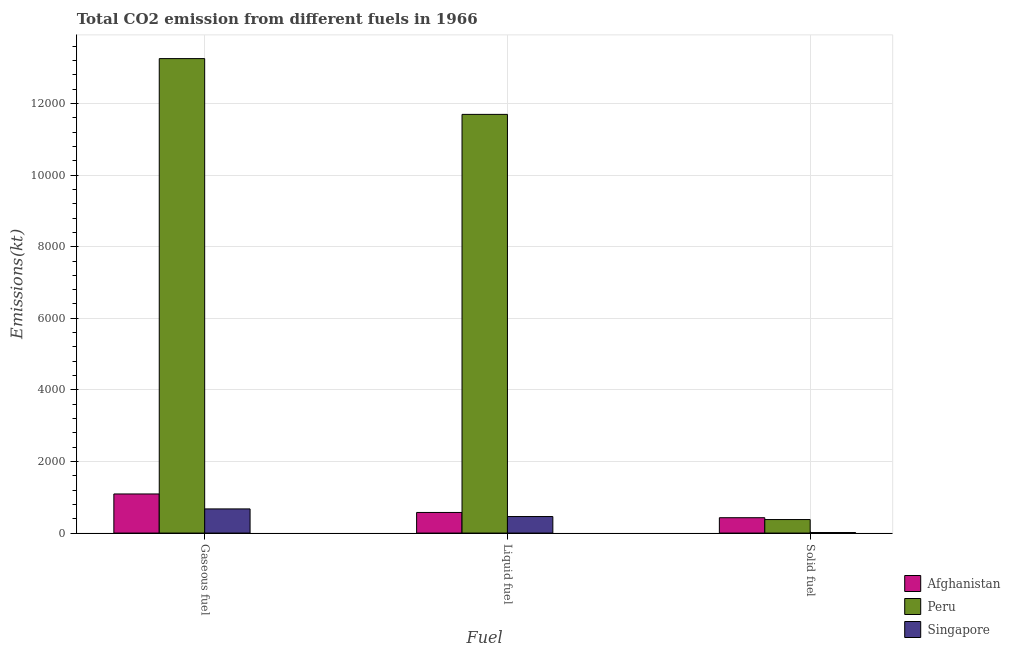How many groups of bars are there?
Keep it short and to the point. 3. How many bars are there on the 1st tick from the left?
Make the answer very short. 3. How many bars are there on the 3rd tick from the right?
Offer a very short reply. 3. What is the label of the 3rd group of bars from the left?
Your response must be concise. Solid fuel. What is the amount of co2 emissions from gaseous fuel in Singapore?
Ensure brevity in your answer.  674.73. Across all countries, what is the maximum amount of co2 emissions from gaseous fuel?
Offer a very short reply. 1.33e+04. Across all countries, what is the minimum amount of co2 emissions from liquid fuel?
Your answer should be very brief. 462.04. In which country was the amount of co2 emissions from gaseous fuel maximum?
Keep it short and to the point. Peru. In which country was the amount of co2 emissions from solid fuel minimum?
Offer a terse response. Singapore. What is the total amount of co2 emissions from gaseous fuel in the graph?
Keep it short and to the point. 1.50e+04. What is the difference between the amount of co2 emissions from gaseous fuel in Afghanistan and that in Peru?
Offer a very short reply. -1.22e+04. What is the difference between the amount of co2 emissions from gaseous fuel in Peru and the amount of co2 emissions from liquid fuel in Afghanistan?
Give a very brief answer. 1.27e+04. What is the average amount of co2 emissions from gaseous fuel per country?
Give a very brief answer. 5007.9. What is the difference between the amount of co2 emissions from solid fuel and amount of co2 emissions from gaseous fuel in Afghanistan?
Offer a very short reply. -663.73. What is the ratio of the amount of co2 emissions from solid fuel in Afghanistan to that in Peru?
Keep it short and to the point. 1.14. Is the amount of co2 emissions from gaseous fuel in Peru less than that in Singapore?
Give a very brief answer. No. What is the difference between the highest and the second highest amount of co2 emissions from liquid fuel?
Offer a very short reply. 1.11e+04. What is the difference between the highest and the lowest amount of co2 emissions from solid fuel?
Keep it short and to the point. 414.37. Is the sum of the amount of co2 emissions from gaseous fuel in Singapore and Peru greater than the maximum amount of co2 emissions from solid fuel across all countries?
Give a very brief answer. Yes. What does the 1st bar from the right in Solid fuel represents?
Offer a very short reply. Singapore. Is it the case that in every country, the sum of the amount of co2 emissions from gaseous fuel and amount of co2 emissions from liquid fuel is greater than the amount of co2 emissions from solid fuel?
Your response must be concise. Yes. How many countries are there in the graph?
Provide a succinct answer. 3. Where does the legend appear in the graph?
Your answer should be very brief. Bottom right. What is the title of the graph?
Provide a short and direct response. Total CO2 emission from different fuels in 1966. Does "Bhutan" appear as one of the legend labels in the graph?
Provide a succinct answer. No. What is the label or title of the X-axis?
Offer a very short reply. Fuel. What is the label or title of the Y-axis?
Make the answer very short. Emissions(kt). What is the Emissions(kt) in Afghanistan in Gaseous fuel?
Make the answer very short. 1092.77. What is the Emissions(kt) in Peru in Gaseous fuel?
Your answer should be compact. 1.33e+04. What is the Emissions(kt) of Singapore in Gaseous fuel?
Ensure brevity in your answer.  674.73. What is the Emissions(kt) of Afghanistan in Liquid fuel?
Give a very brief answer. 575.72. What is the Emissions(kt) in Peru in Liquid fuel?
Offer a terse response. 1.17e+04. What is the Emissions(kt) of Singapore in Liquid fuel?
Your answer should be compact. 462.04. What is the Emissions(kt) of Afghanistan in Solid fuel?
Make the answer very short. 429.04. What is the Emissions(kt) of Peru in Solid fuel?
Ensure brevity in your answer.  377.7. What is the Emissions(kt) of Singapore in Solid fuel?
Give a very brief answer. 14.67. Across all Fuel, what is the maximum Emissions(kt) in Afghanistan?
Offer a terse response. 1092.77. Across all Fuel, what is the maximum Emissions(kt) of Peru?
Give a very brief answer. 1.33e+04. Across all Fuel, what is the maximum Emissions(kt) in Singapore?
Your response must be concise. 674.73. Across all Fuel, what is the minimum Emissions(kt) of Afghanistan?
Offer a terse response. 429.04. Across all Fuel, what is the minimum Emissions(kt) in Peru?
Offer a terse response. 377.7. Across all Fuel, what is the minimum Emissions(kt) in Singapore?
Provide a succinct answer. 14.67. What is the total Emissions(kt) in Afghanistan in the graph?
Your answer should be compact. 2097.52. What is the total Emissions(kt) in Peru in the graph?
Offer a terse response. 2.53e+04. What is the total Emissions(kt) of Singapore in the graph?
Keep it short and to the point. 1151.44. What is the difference between the Emissions(kt) in Afghanistan in Gaseous fuel and that in Liquid fuel?
Give a very brief answer. 517.05. What is the difference between the Emissions(kt) of Peru in Gaseous fuel and that in Liquid fuel?
Your response must be concise. 1558.47. What is the difference between the Emissions(kt) of Singapore in Gaseous fuel and that in Liquid fuel?
Make the answer very short. 212.69. What is the difference between the Emissions(kt) of Afghanistan in Gaseous fuel and that in Solid fuel?
Provide a succinct answer. 663.73. What is the difference between the Emissions(kt) in Peru in Gaseous fuel and that in Solid fuel?
Ensure brevity in your answer.  1.29e+04. What is the difference between the Emissions(kt) in Singapore in Gaseous fuel and that in Solid fuel?
Provide a succinct answer. 660.06. What is the difference between the Emissions(kt) of Afghanistan in Liquid fuel and that in Solid fuel?
Keep it short and to the point. 146.68. What is the difference between the Emissions(kt) in Peru in Liquid fuel and that in Solid fuel?
Give a very brief answer. 1.13e+04. What is the difference between the Emissions(kt) in Singapore in Liquid fuel and that in Solid fuel?
Your answer should be very brief. 447.37. What is the difference between the Emissions(kt) of Afghanistan in Gaseous fuel and the Emissions(kt) of Peru in Liquid fuel?
Make the answer very short. -1.06e+04. What is the difference between the Emissions(kt) in Afghanistan in Gaseous fuel and the Emissions(kt) in Singapore in Liquid fuel?
Provide a succinct answer. 630.72. What is the difference between the Emissions(kt) in Peru in Gaseous fuel and the Emissions(kt) in Singapore in Liquid fuel?
Make the answer very short. 1.28e+04. What is the difference between the Emissions(kt) of Afghanistan in Gaseous fuel and the Emissions(kt) of Peru in Solid fuel?
Make the answer very short. 715.07. What is the difference between the Emissions(kt) in Afghanistan in Gaseous fuel and the Emissions(kt) in Singapore in Solid fuel?
Offer a terse response. 1078.1. What is the difference between the Emissions(kt) of Peru in Gaseous fuel and the Emissions(kt) of Singapore in Solid fuel?
Offer a terse response. 1.32e+04. What is the difference between the Emissions(kt) of Afghanistan in Liquid fuel and the Emissions(kt) of Peru in Solid fuel?
Provide a succinct answer. 198.02. What is the difference between the Emissions(kt) of Afghanistan in Liquid fuel and the Emissions(kt) of Singapore in Solid fuel?
Your response must be concise. 561.05. What is the difference between the Emissions(kt) of Peru in Liquid fuel and the Emissions(kt) of Singapore in Solid fuel?
Your answer should be very brief. 1.17e+04. What is the average Emissions(kt) of Afghanistan per Fuel?
Provide a succinct answer. 699.17. What is the average Emissions(kt) of Peru per Fuel?
Offer a very short reply. 8443.88. What is the average Emissions(kt) in Singapore per Fuel?
Provide a short and direct response. 383.81. What is the difference between the Emissions(kt) of Afghanistan and Emissions(kt) of Peru in Gaseous fuel?
Keep it short and to the point. -1.22e+04. What is the difference between the Emissions(kt) in Afghanistan and Emissions(kt) in Singapore in Gaseous fuel?
Ensure brevity in your answer.  418.04. What is the difference between the Emissions(kt) in Peru and Emissions(kt) in Singapore in Gaseous fuel?
Offer a very short reply. 1.26e+04. What is the difference between the Emissions(kt) of Afghanistan and Emissions(kt) of Peru in Liquid fuel?
Offer a terse response. -1.11e+04. What is the difference between the Emissions(kt) in Afghanistan and Emissions(kt) in Singapore in Liquid fuel?
Keep it short and to the point. 113.68. What is the difference between the Emissions(kt) in Peru and Emissions(kt) in Singapore in Liquid fuel?
Give a very brief answer. 1.12e+04. What is the difference between the Emissions(kt) of Afghanistan and Emissions(kt) of Peru in Solid fuel?
Your response must be concise. 51.34. What is the difference between the Emissions(kt) in Afghanistan and Emissions(kt) in Singapore in Solid fuel?
Make the answer very short. 414.37. What is the difference between the Emissions(kt) in Peru and Emissions(kt) in Singapore in Solid fuel?
Provide a succinct answer. 363.03. What is the ratio of the Emissions(kt) in Afghanistan in Gaseous fuel to that in Liquid fuel?
Offer a terse response. 1.9. What is the ratio of the Emissions(kt) of Peru in Gaseous fuel to that in Liquid fuel?
Make the answer very short. 1.13. What is the ratio of the Emissions(kt) in Singapore in Gaseous fuel to that in Liquid fuel?
Your answer should be compact. 1.46. What is the ratio of the Emissions(kt) in Afghanistan in Gaseous fuel to that in Solid fuel?
Give a very brief answer. 2.55. What is the ratio of the Emissions(kt) of Peru in Gaseous fuel to that in Solid fuel?
Offer a very short reply. 35.1. What is the ratio of the Emissions(kt) in Afghanistan in Liquid fuel to that in Solid fuel?
Make the answer very short. 1.34. What is the ratio of the Emissions(kt) in Peru in Liquid fuel to that in Solid fuel?
Ensure brevity in your answer.  30.97. What is the ratio of the Emissions(kt) of Singapore in Liquid fuel to that in Solid fuel?
Your response must be concise. 31.5. What is the difference between the highest and the second highest Emissions(kt) in Afghanistan?
Make the answer very short. 517.05. What is the difference between the highest and the second highest Emissions(kt) in Peru?
Make the answer very short. 1558.47. What is the difference between the highest and the second highest Emissions(kt) in Singapore?
Provide a short and direct response. 212.69. What is the difference between the highest and the lowest Emissions(kt) of Afghanistan?
Your answer should be compact. 663.73. What is the difference between the highest and the lowest Emissions(kt) of Peru?
Offer a very short reply. 1.29e+04. What is the difference between the highest and the lowest Emissions(kt) of Singapore?
Provide a short and direct response. 660.06. 